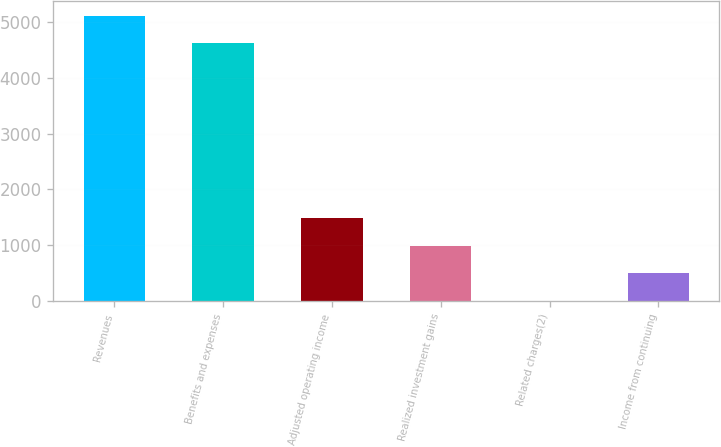<chart> <loc_0><loc_0><loc_500><loc_500><bar_chart><fcel>Revenues<fcel>Benefits and expenses<fcel>Adjusted operating income<fcel>Realized investment gains<fcel>Related charges(2)<fcel>Income from continuing<nl><fcel>5115.9<fcel>4620<fcel>1488.7<fcel>992.8<fcel>1<fcel>496.9<nl></chart> 